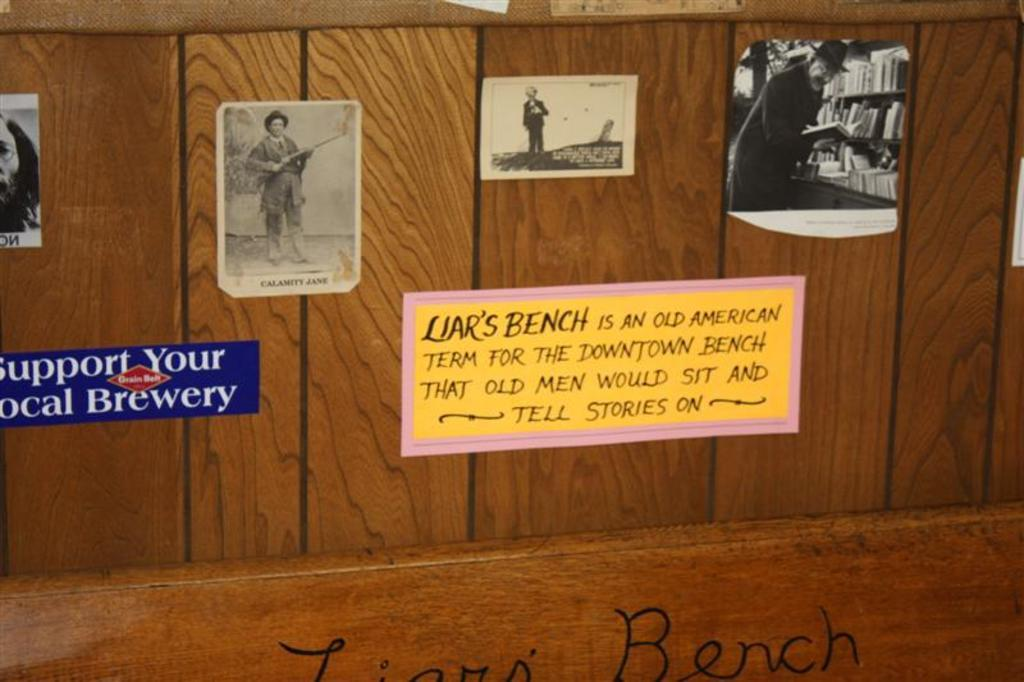<image>
Share a concise interpretation of the image provided. Wooden planks with various pictures attached including a sign that reads "support you local brewery" 